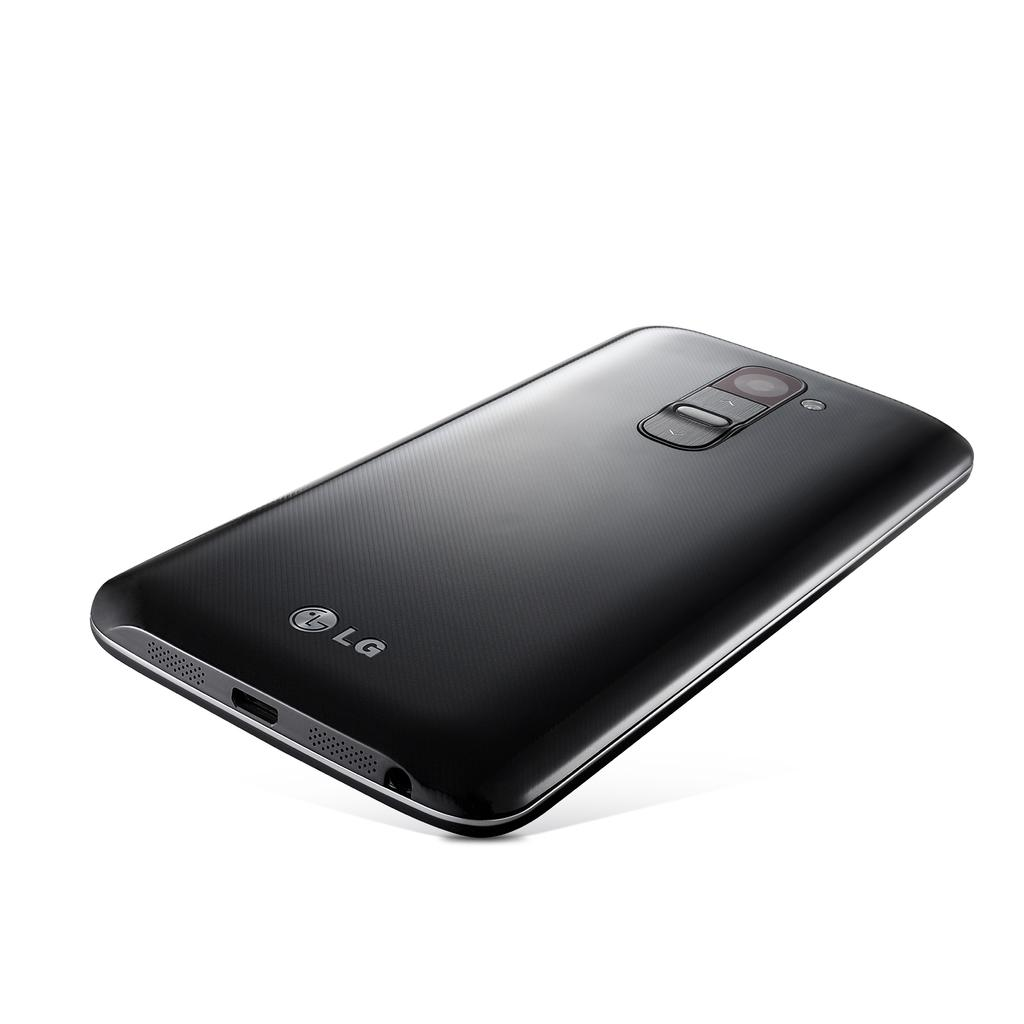<image>
Provide a brief description of the given image. the back of an LG phone sits on a white backdrop 